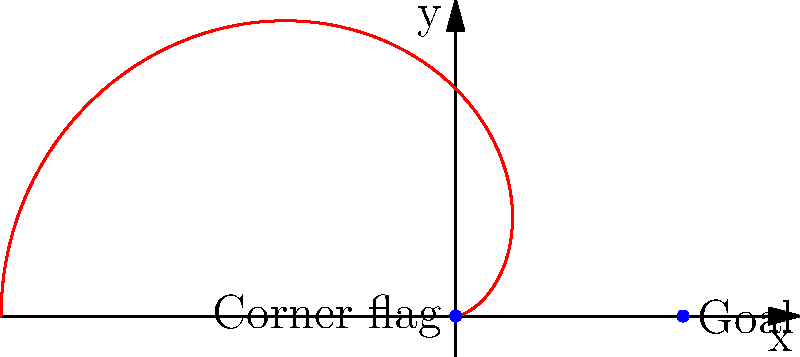As a Cambridge United analyst, you're studying corner kick trajectories. The path of a corner kick can be modeled using the polar equation $r = 30(1-\cos\theta)$, where $r$ is in meters. If the corner flag is at the origin and the center of the goal is 30 meters away on the x-axis, what is the maximum height (in meters) the ball reaches during its trajectory? To find the maximum height of the ball's trajectory, we need to follow these steps:

1) The given polar equation is $r = 30(1-\cos\theta)$.

2) The maximum height will occur when $\theta = \frac{\pi}{2}$ (90 degrees), as this is when the ball reaches its highest point vertically.

3) To find the y-coordinate (height) at this point, we need to convert from polar to Cartesian coordinates:
   
   $x = r\cos\theta$
   $y = r\sin\theta$

4) At $\theta = \frac{\pi}{2}$, we have:
   
   $r = 30(1-\cos\frac{\pi}{2}) = 30(1-0) = 30$

5) Now we can calculate y:
   
   $y = r\sin\theta = 30\sin\frac{\pi}{2} = 30 \cdot 1 = 30$

Therefore, the maximum height the ball reaches is 30 meters.
Answer: 30 meters 